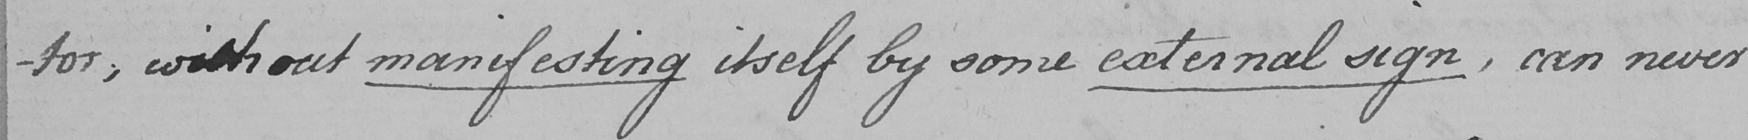Transcribe the text shown in this historical manuscript line. -tor , with out manifesting itself by some external sign,can never 